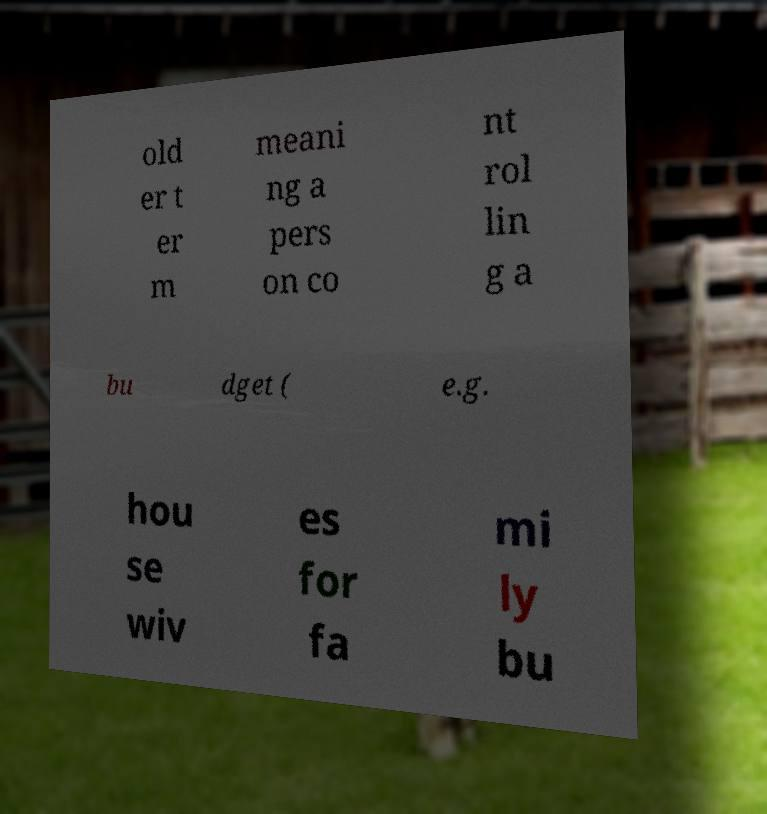I need the written content from this picture converted into text. Can you do that? old er t er m meani ng a pers on co nt rol lin g a bu dget ( e.g. hou se wiv es for fa mi ly bu 